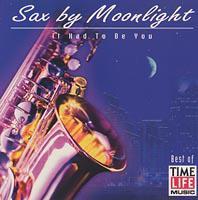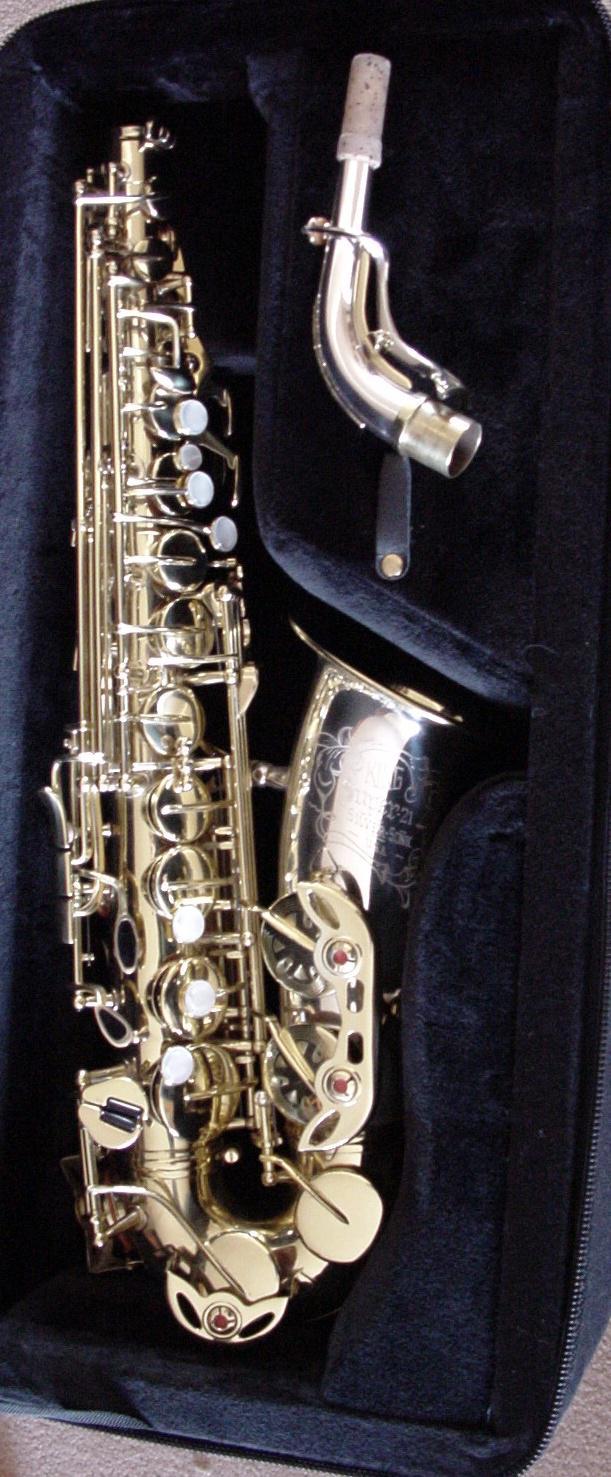The first image is the image on the left, the second image is the image on the right. For the images shown, is this caption "There is an image of a saxophone with its neck removed from the body of the instrument." true? Answer yes or no. Yes. 